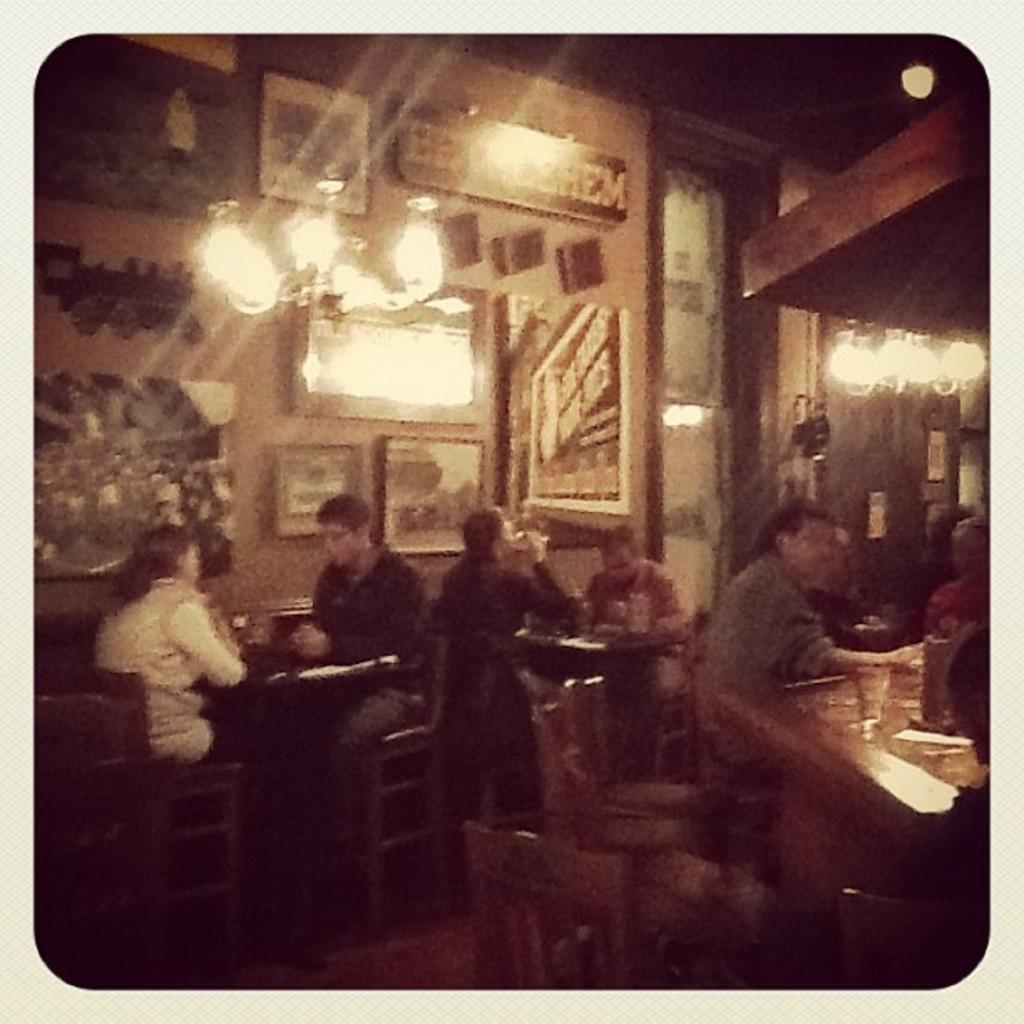What is hanging on the wall in the image? There are pictures on the wall. What is located above the pictures? There are lights on top. What are the people in the image doing? People are sitting on chairs. What objects are in front of the chairs? There are tables in front of the chairs. How many frogs are sitting on the chairs in the image? There are no frogs present in the image; people are sitting on the chairs. What type of shoes are the people wearing in the image? There is no information about shoes in the image; people are sitting on chairs. 